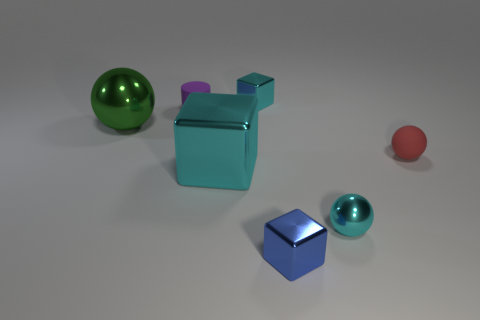If these objects were real, what materials might they be made of? Based on their appearance, these objects might be made of polished metal or plastic, as suggested by their reflective and shiny surfaces. 